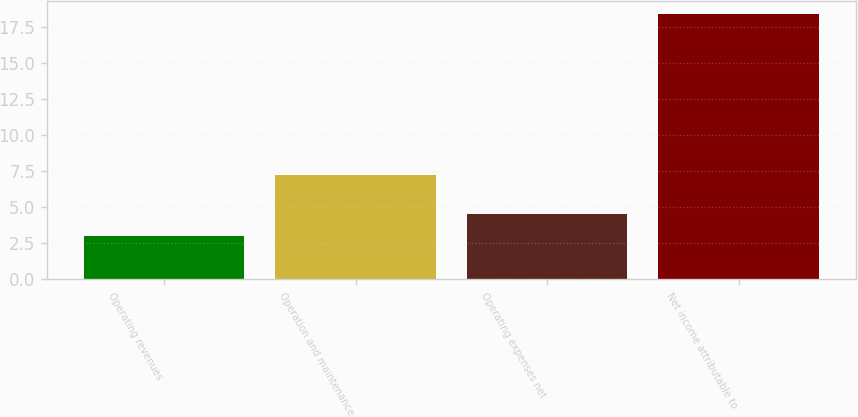<chart> <loc_0><loc_0><loc_500><loc_500><bar_chart><fcel>Operating revenues<fcel>Operation and maintenance<fcel>Operating expenses net<fcel>Net income attributable to<nl><fcel>3<fcel>7.2<fcel>4.54<fcel>18.4<nl></chart> 